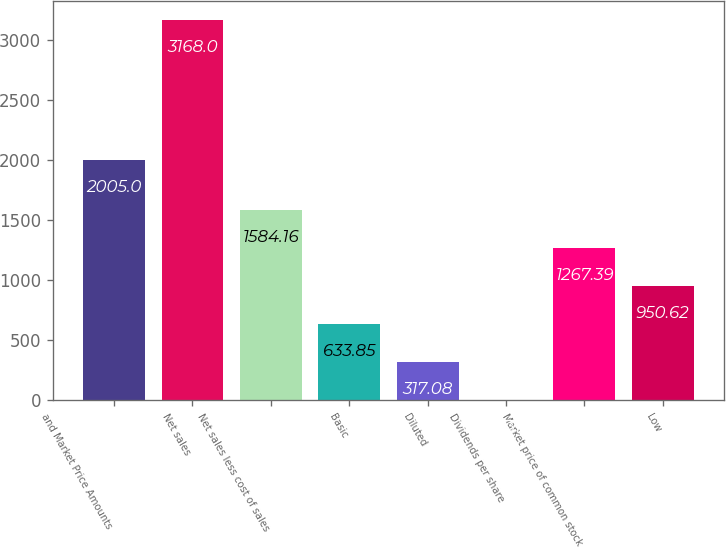<chart> <loc_0><loc_0><loc_500><loc_500><bar_chart><fcel>and Market Price Amounts<fcel>Net sales<fcel>Net sales less cost of sales<fcel>Basic<fcel>Diluted<fcel>Dividends per share<fcel>Market price of common stock<fcel>Low<nl><fcel>2005<fcel>3168<fcel>1584.16<fcel>633.85<fcel>317.08<fcel>0.31<fcel>1267.39<fcel>950.62<nl></chart> 